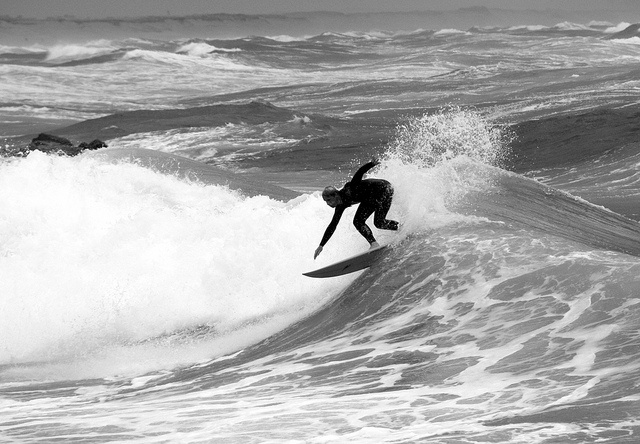Describe the objects in this image and their specific colors. I can see people in gray, black, darkgray, and lightgray tones and surfboard in gray, black, darkgray, and lightgray tones in this image. 